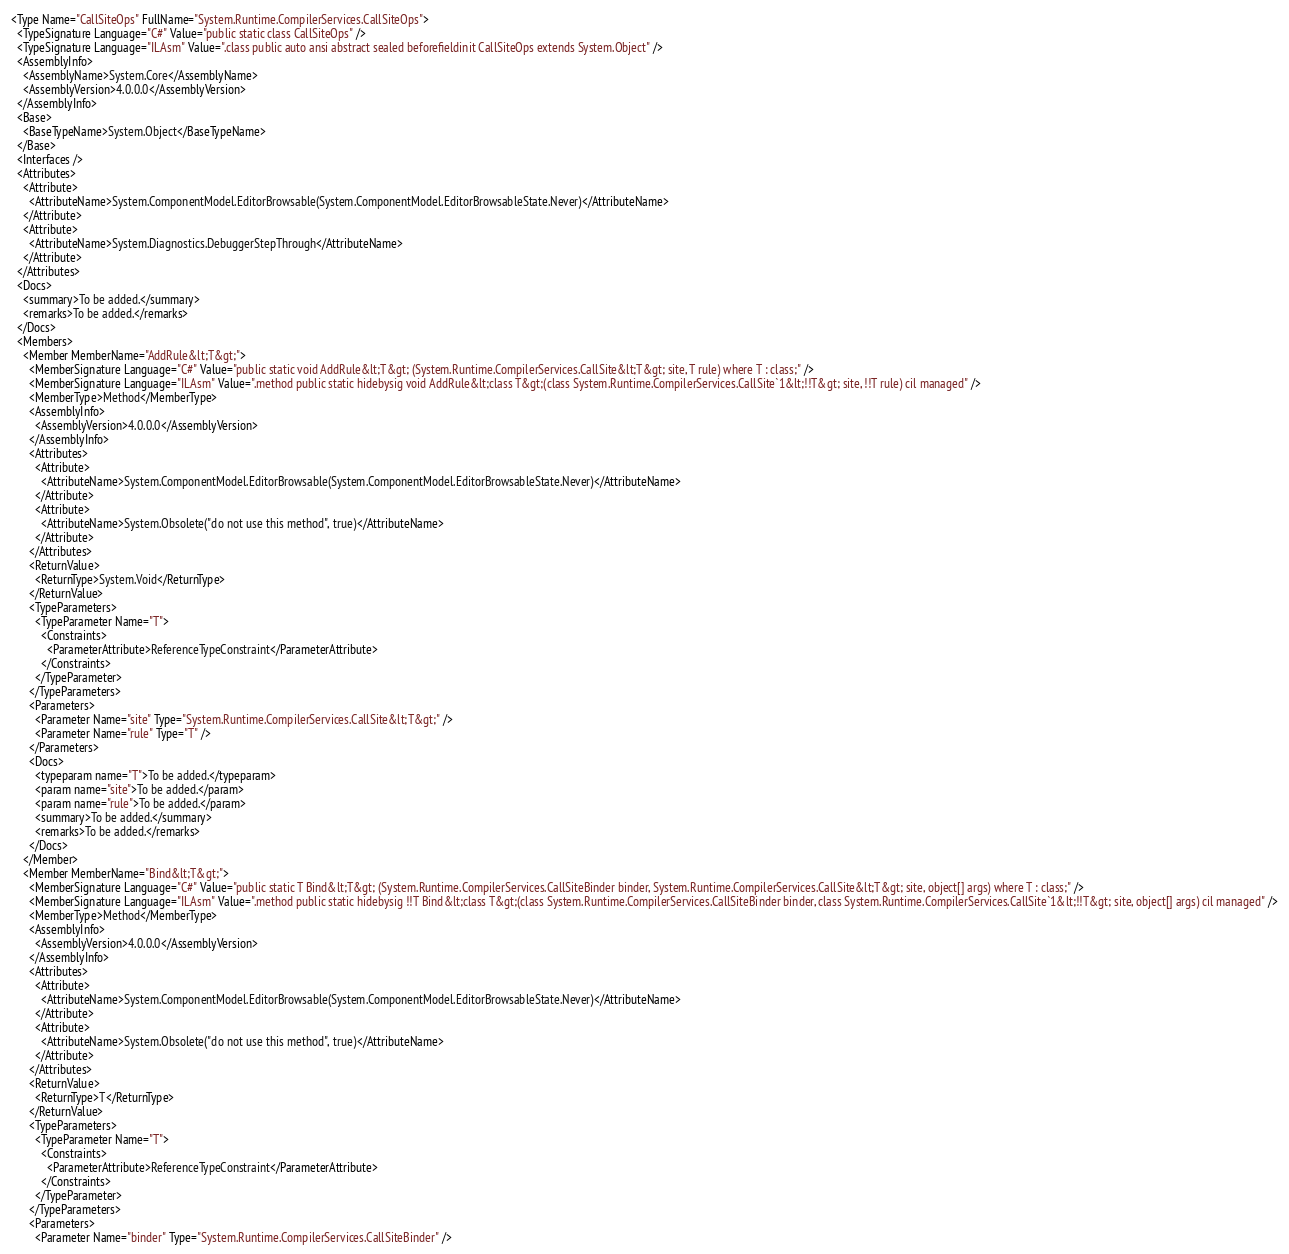Convert code to text. <code><loc_0><loc_0><loc_500><loc_500><_XML_><Type Name="CallSiteOps" FullName="System.Runtime.CompilerServices.CallSiteOps">
  <TypeSignature Language="C#" Value="public static class CallSiteOps" />
  <TypeSignature Language="ILAsm" Value=".class public auto ansi abstract sealed beforefieldinit CallSiteOps extends System.Object" />
  <AssemblyInfo>
    <AssemblyName>System.Core</AssemblyName>
    <AssemblyVersion>4.0.0.0</AssemblyVersion>
  </AssemblyInfo>
  <Base>
    <BaseTypeName>System.Object</BaseTypeName>
  </Base>
  <Interfaces />
  <Attributes>
    <Attribute>
      <AttributeName>System.ComponentModel.EditorBrowsable(System.ComponentModel.EditorBrowsableState.Never)</AttributeName>
    </Attribute>
    <Attribute>
      <AttributeName>System.Diagnostics.DebuggerStepThrough</AttributeName>
    </Attribute>
  </Attributes>
  <Docs>
    <summary>To be added.</summary>
    <remarks>To be added.</remarks>
  </Docs>
  <Members>
    <Member MemberName="AddRule&lt;T&gt;">
      <MemberSignature Language="C#" Value="public static void AddRule&lt;T&gt; (System.Runtime.CompilerServices.CallSite&lt;T&gt; site, T rule) where T : class;" />
      <MemberSignature Language="ILAsm" Value=".method public static hidebysig void AddRule&lt;class T&gt;(class System.Runtime.CompilerServices.CallSite`1&lt;!!T&gt; site, !!T rule) cil managed" />
      <MemberType>Method</MemberType>
      <AssemblyInfo>
        <AssemblyVersion>4.0.0.0</AssemblyVersion>
      </AssemblyInfo>
      <Attributes>
        <Attribute>
          <AttributeName>System.ComponentModel.EditorBrowsable(System.ComponentModel.EditorBrowsableState.Never)</AttributeName>
        </Attribute>
        <Attribute>
          <AttributeName>System.Obsolete("do not use this method", true)</AttributeName>
        </Attribute>
      </Attributes>
      <ReturnValue>
        <ReturnType>System.Void</ReturnType>
      </ReturnValue>
      <TypeParameters>
        <TypeParameter Name="T">
          <Constraints>
            <ParameterAttribute>ReferenceTypeConstraint</ParameterAttribute>
          </Constraints>
        </TypeParameter>
      </TypeParameters>
      <Parameters>
        <Parameter Name="site" Type="System.Runtime.CompilerServices.CallSite&lt;T&gt;" />
        <Parameter Name="rule" Type="T" />
      </Parameters>
      <Docs>
        <typeparam name="T">To be added.</typeparam>
        <param name="site">To be added.</param>
        <param name="rule">To be added.</param>
        <summary>To be added.</summary>
        <remarks>To be added.</remarks>
      </Docs>
    </Member>
    <Member MemberName="Bind&lt;T&gt;">
      <MemberSignature Language="C#" Value="public static T Bind&lt;T&gt; (System.Runtime.CompilerServices.CallSiteBinder binder, System.Runtime.CompilerServices.CallSite&lt;T&gt; site, object[] args) where T : class;" />
      <MemberSignature Language="ILAsm" Value=".method public static hidebysig !!T Bind&lt;class T&gt;(class System.Runtime.CompilerServices.CallSiteBinder binder, class System.Runtime.CompilerServices.CallSite`1&lt;!!T&gt; site, object[] args) cil managed" />
      <MemberType>Method</MemberType>
      <AssemblyInfo>
        <AssemblyVersion>4.0.0.0</AssemblyVersion>
      </AssemblyInfo>
      <Attributes>
        <Attribute>
          <AttributeName>System.ComponentModel.EditorBrowsable(System.ComponentModel.EditorBrowsableState.Never)</AttributeName>
        </Attribute>
        <Attribute>
          <AttributeName>System.Obsolete("do not use this method", true)</AttributeName>
        </Attribute>
      </Attributes>
      <ReturnValue>
        <ReturnType>T</ReturnType>
      </ReturnValue>
      <TypeParameters>
        <TypeParameter Name="T">
          <Constraints>
            <ParameterAttribute>ReferenceTypeConstraint</ParameterAttribute>
          </Constraints>
        </TypeParameter>
      </TypeParameters>
      <Parameters>
        <Parameter Name="binder" Type="System.Runtime.CompilerServices.CallSiteBinder" /></code> 